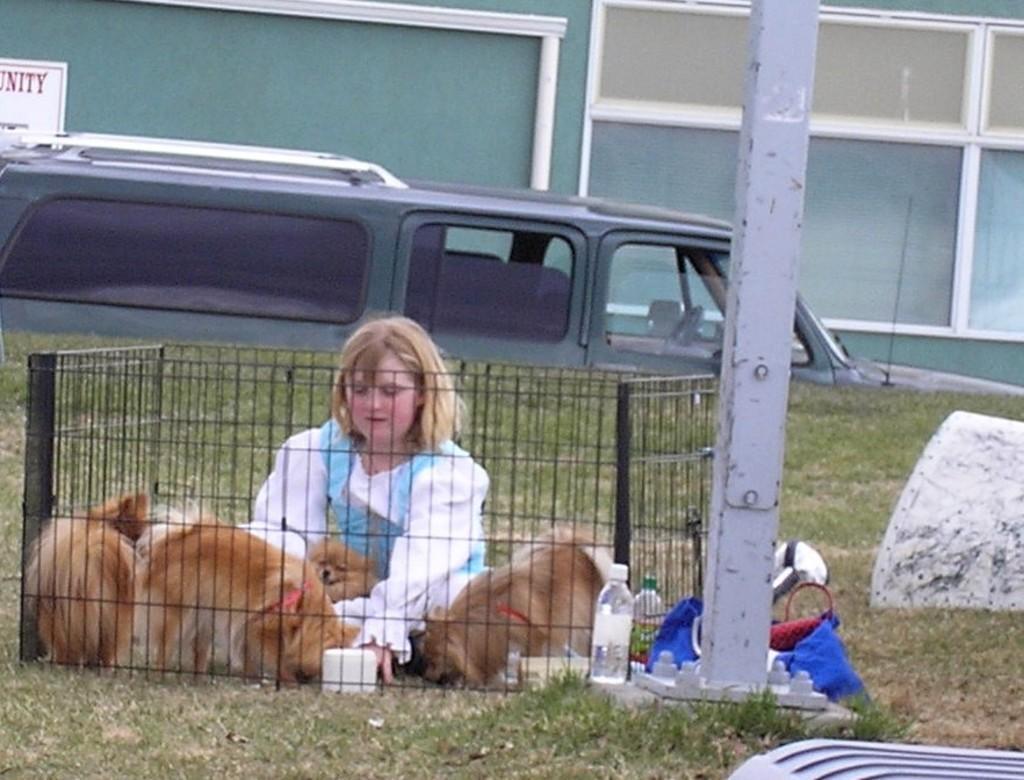Could you give a brief overview of what you see in this image? In the foreground of the picture there are grass, water bottle, bag, iron pole, cage, girl and dogs. In the background there are vehicles. At the top there is a building. 